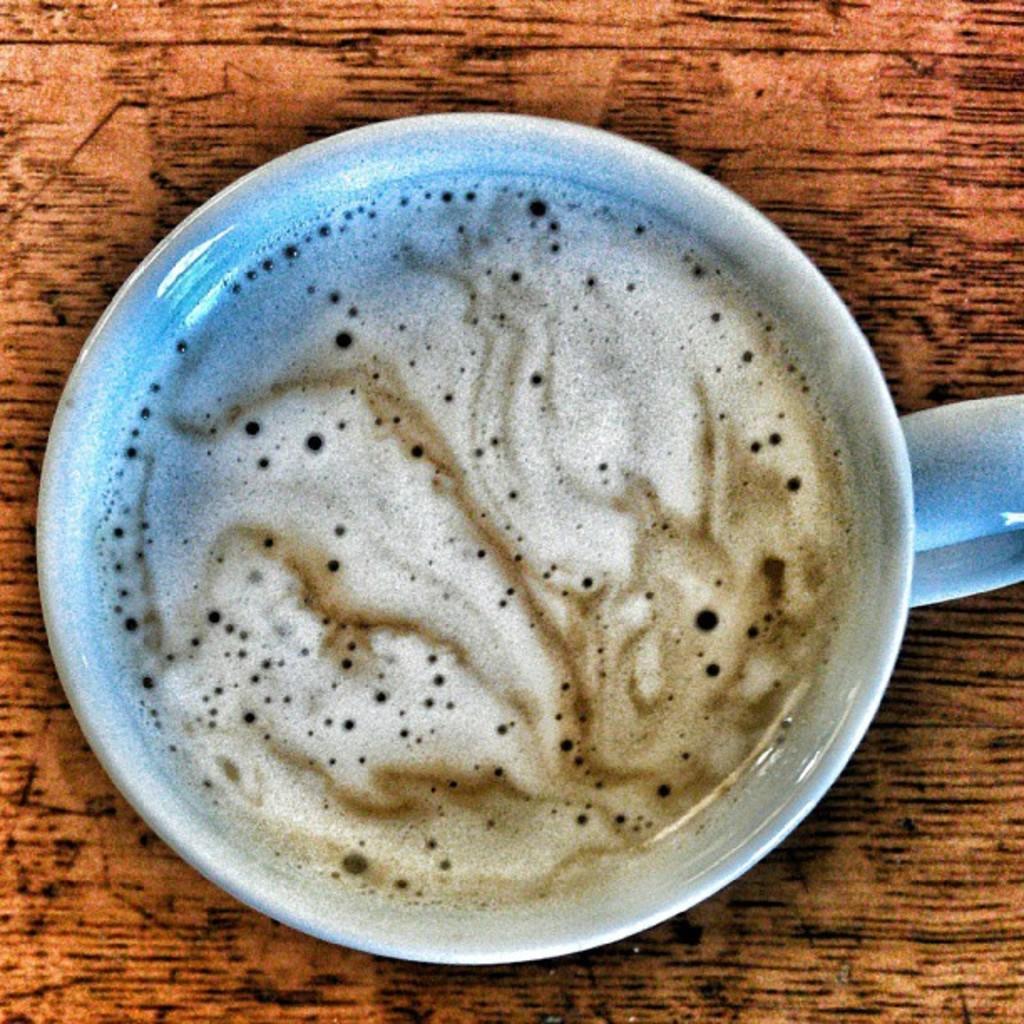Can you describe this image briefly? In this image there is a coffee in a cup which was placed on the table. 